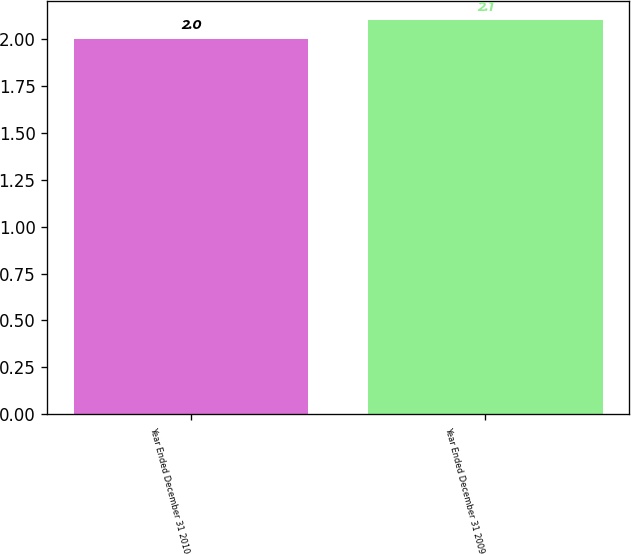<chart> <loc_0><loc_0><loc_500><loc_500><bar_chart><fcel>Year Ended December 31 2010<fcel>Year Ended December 31 2009<nl><fcel>2<fcel>2.1<nl></chart> 